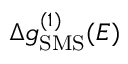Convert formula to latex. <formula><loc_0><loc_0><loc_500><loc_500>\Delta g _ { S M S } ^ { ( 1 ) } ( E )</formula> 